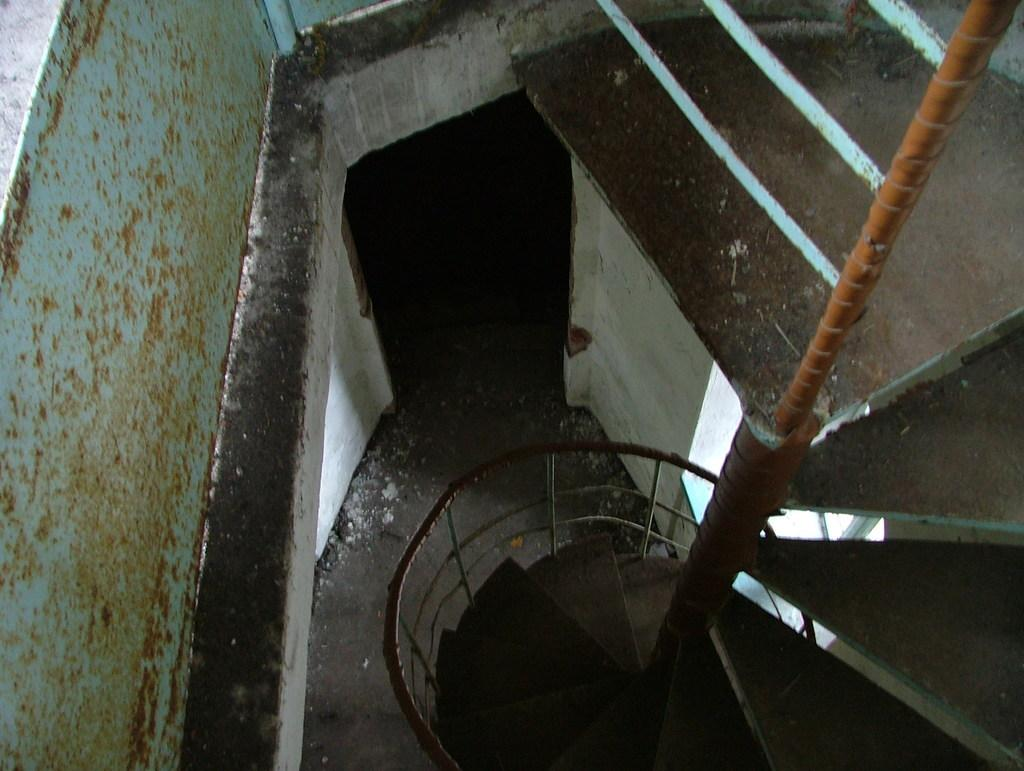What type of architectural feature is present in the image? There are stairs in the image. What safety feature is present alongside the stairs? There is a railing in the image. What surface can be seen at the bottom of the stairs? The floor is visible in the image. What type of structure is present in the background of the image? There is a wall in the image. What object is present near the wall? There is a rod in the image. What type of paper is being used to illuminate the area in the image? There is no paper or bulb present in the image; the image only shows stairs, a railing, the floor, a wall, and a rod. 